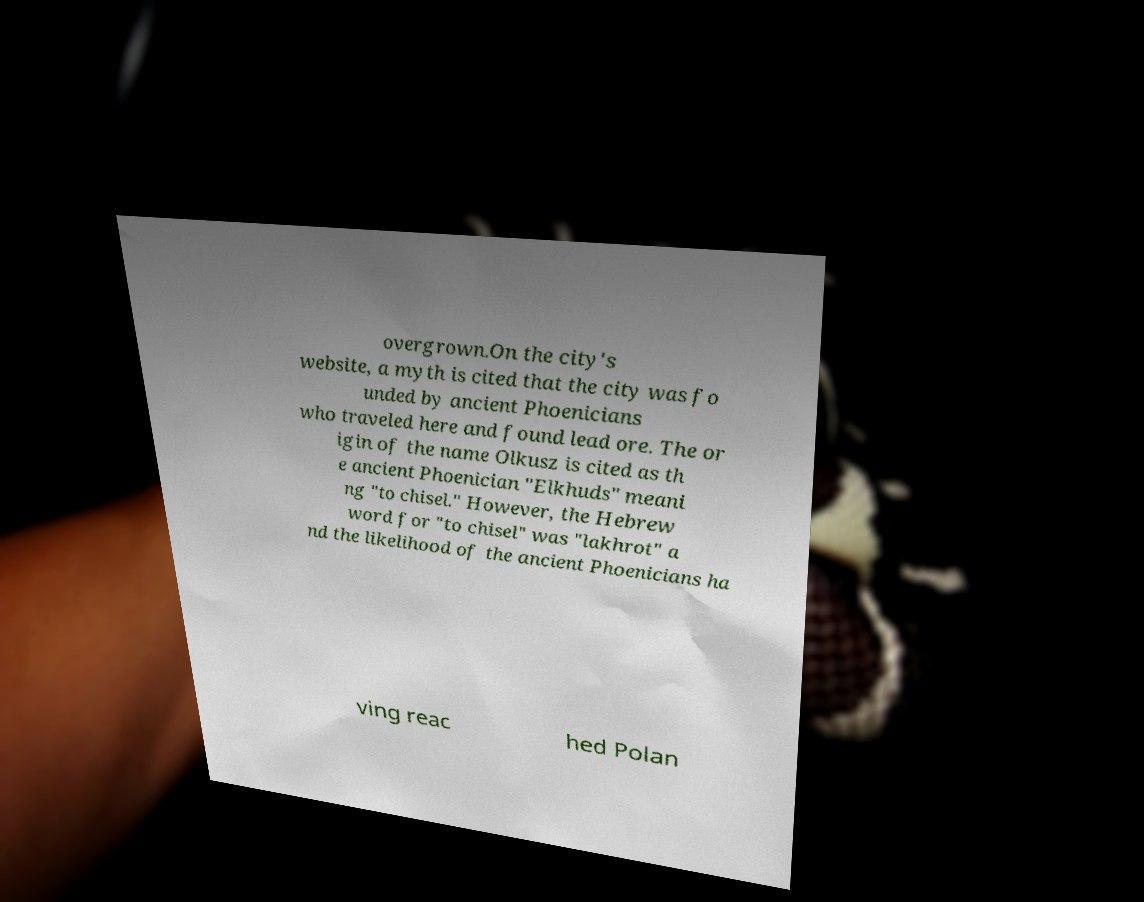Please read and relay the text visible in this image. What does it say? overgrown.On the city's website, a myth is cited that the city was fo unded by ancient Phoenicians who traveled here and found lead ore. The or igin of the name Olkusz is cited as th e ancient Phoenician "Elkhuds" meani ng "to chisel." However, the Hebrew word for "to chisel" was "lakhrot" a nd the likelihood of the ancient Phoenicians ha ving reac hed Polan 